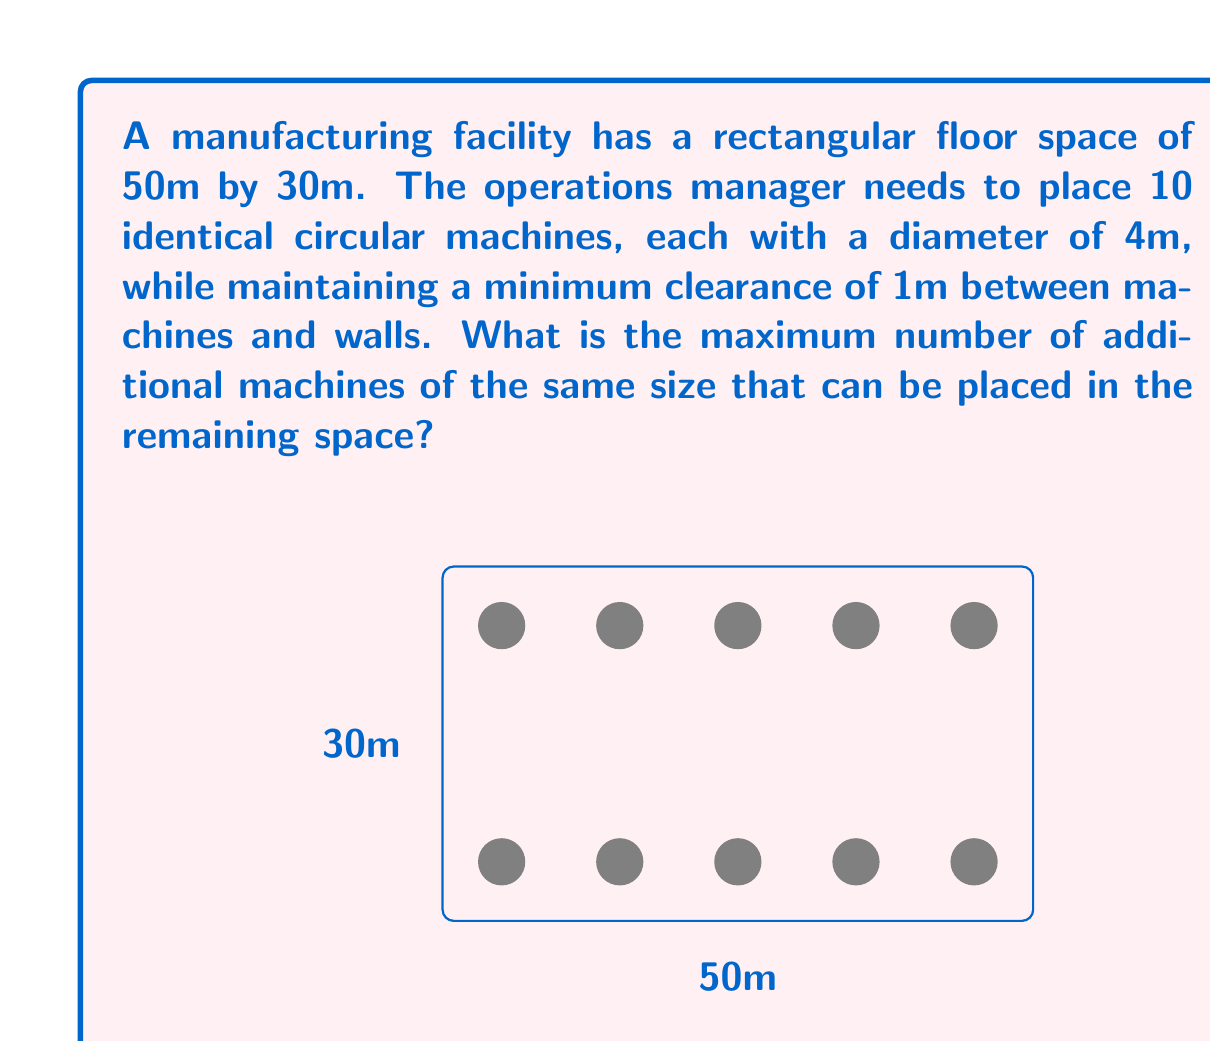What is the answer to this math problem? Let's approach this step-by-step:

1) First, we need to calculate the effective space available after considering the clearance:
   Effective length = $50m - 2 \times 1m = 48m$
   Effective width = $30m - 2 \times 1m = 28m$

2) Each machine, including its clearance, occupies a square of:
   $(4m + 1m + 1m) \times (4m + 1m + 1m) = 6m \times 6m = 36m^2$

3) The current arrangement of 10 machines forms two rows of 5 machines each:
   Row length = $5 \times 6m = 30m$
   Two rows height = $2 \times 6m = 12m$

4) Remaining space:
   Length-wise: $48m - 30m = 18m$ (enough for 3 more machines)
   Width-wise: $28m - 12m = 16m$ (enough for 2 more rows)

5) We can fit:
   3 machines in the remaining length
   2 rows of 5 machines each in the remaining width

6) Total additional machines:
   $3 + (2 \times 5) = 13$

Therefore, 13 additional machines can be placed in the remaining space.
Answer: 13 machines 